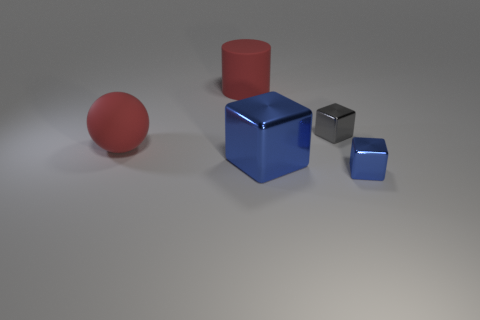What number of things are either red objects that are in front of the red cylinder or red metallic cylinders?
Your response must be concise. 1. What is the cylinder made of?
Provide a short and direct response. Rubber. Do the red matte ball and the gray metallic object have the same size?
Provide a short and direct response. No. What number of cubes are brown rubber objects or gray objects?
Offer a very short reply. 1. There is a tiny thing that is in front of the red thing on the left side of the red cylinder; what color is it?
Ensure brevity in your answer.  Blue. Are there fewer large things that are in front of the large shiny cube than big rubber things that are in front of the red sphere?
Offer a terse response. No. There is a sphere; does it have the same size as the metal block behind the red ball?
Your answer should be very brief. No. What shape is the large thing that is in front of the red cylinder and behind the large blue cube?
Your response must be concise. Sphere. What size is the object that is made of the same material as the big sphere?
Your answer should be very brief. Large. How many small blue metal things are behind the gray shiny thing that is behind the tiny blue block?
Your answer should be very brief. 0. 